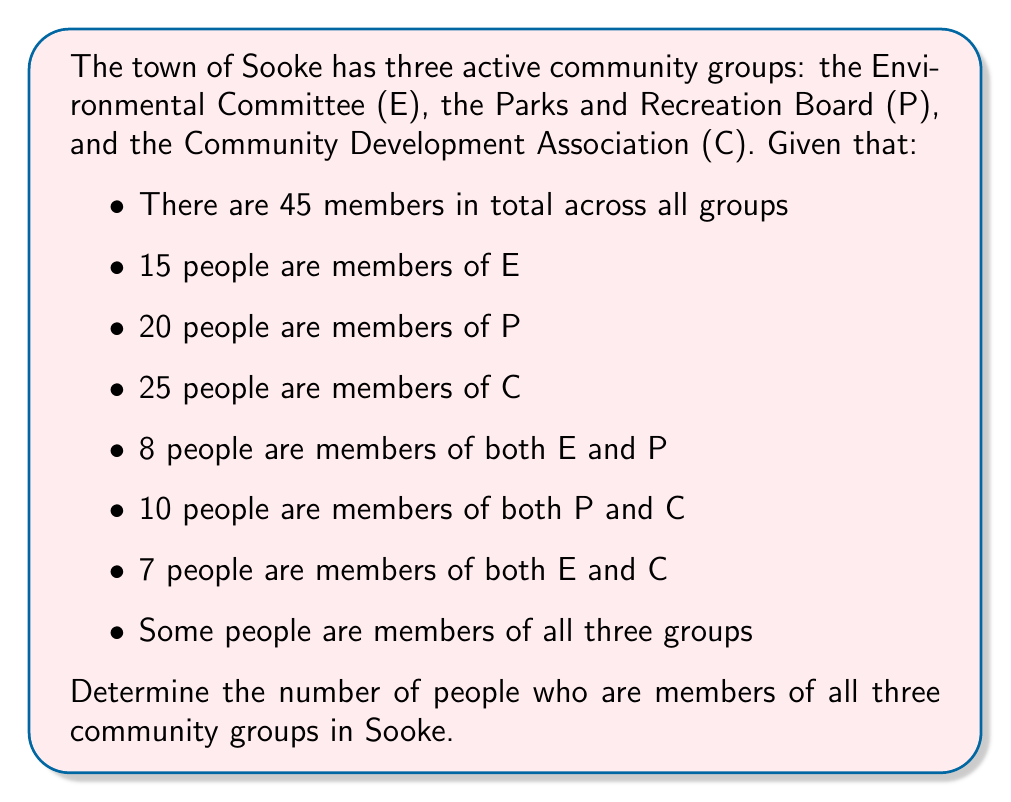Teach me how to tackle this problem. To solve this problem, we'll use the principle of inclusion-exclusion for three sets. Let's define our sets:

$E$: Environmental Committee
$P$: Parks and Recreation Board
$C$: Community Development Association

We're given:
$|E| = 15$
$|P| = 20$
$|C| = 25$
$|E \cap P| = 8$
$|P \cap C| = 10$
$|E \cap C| = 7$
$|E \cup P \cup C| = 45$

Let $x = |E \cap P \cap C|$, which is what we're trying to find.

The principle of inclusion-exclusion for three sets states:

$$|E \cup P \cup C| = |E| + |P| + |C| - |E \cap P| - |P \cap C| - |E \cap C| + |E \cap P \cap C|$$

Substituting our known values:

$$45 = 15 + 20 + 25 - 8 - 10 - 7 + x$$

Simplifying:

$$45 = 35 + x$$

Solving for $x$:

$$x = 45 - 35 = 10$$

Therefore, 10 people are members of all three community groups in Sooke.
Answer: 10 people 